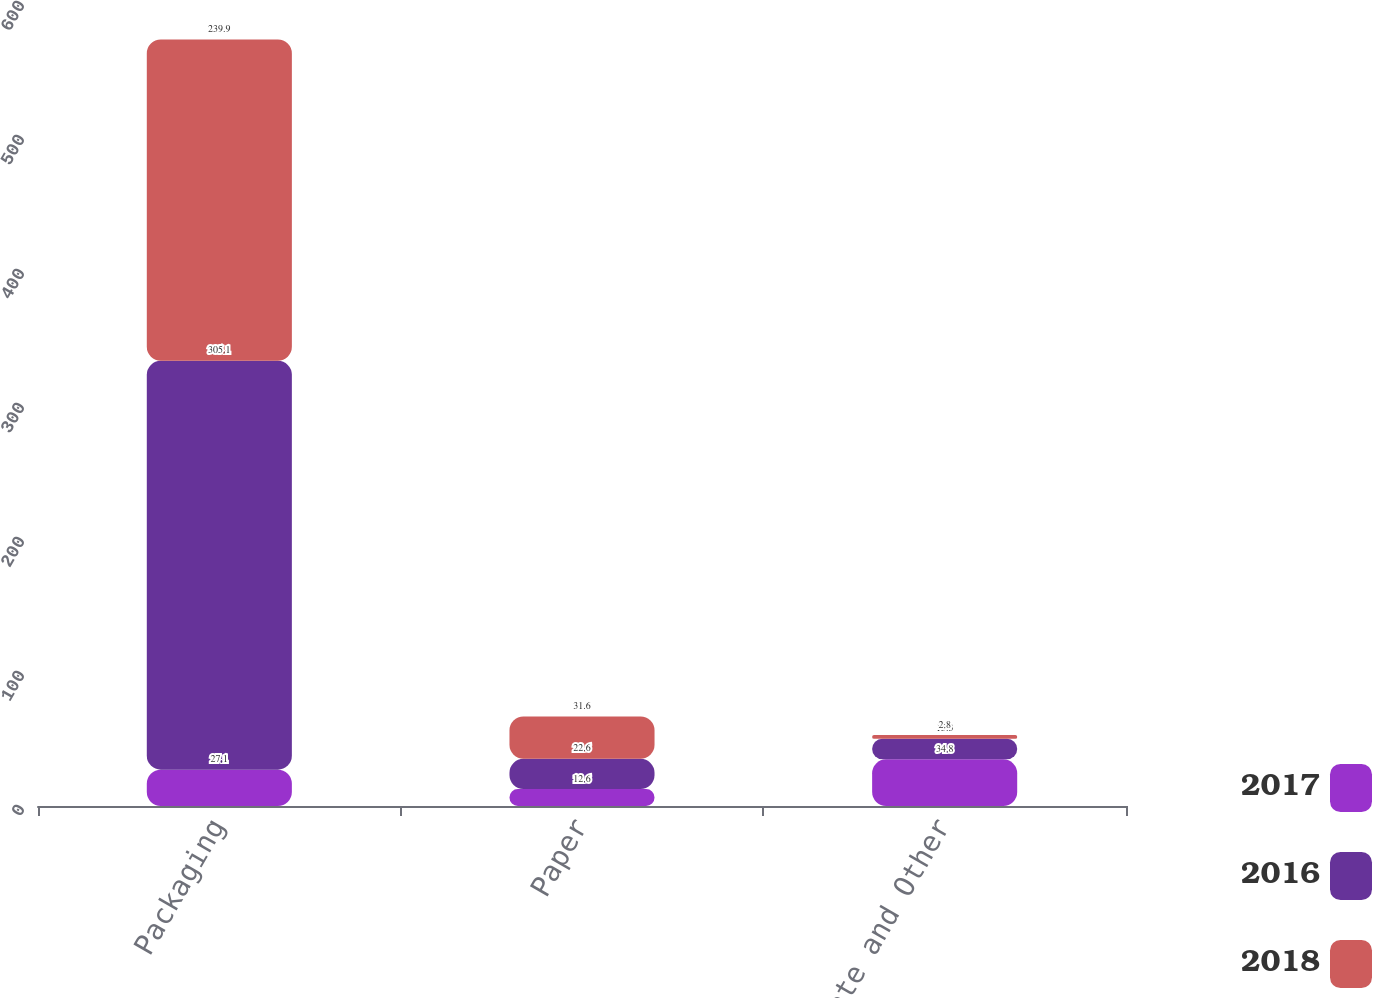Convert chart to OTSL. <chart><loc_0><loc_0><loc_500><loc_500><stacked_bar_chart><ecel><fcel>Packaging<fcel>Paper<fcel>Corporate and Other<nl><fcel>2017<fcel>27.1<fcel>12.6<fcel>34.8<nl><fcel>2016<fcel>305.1<fcel>22.6<fcel>15.3<nl><fcel>2018<fcel>239.9<fcel>31.6<fcel>2.8<nl></chart> 